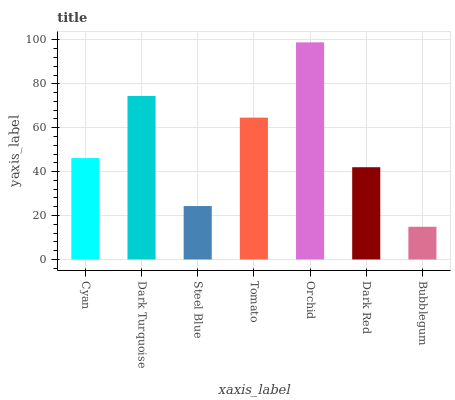Is Bubblegum the minimum?
Answer yes or no. Yes. Is Orchid the maximum?
Answer yes or no. Yes. Is Dark Turquoise the minimum?
Answer yes or no. No. Is Dark Turquoise the maximum?
Answer yes or no. No. Is Dark Turquoise greater than Cyan?
Answer yes or no. Yes. Is Cyan less than Dark Turquoise?
Answer yes or no. Yes. Is Cyan greater than Dark Turquoise?
Answer yes or no. No. Is Dark Turquoise less than Cyan?
Answer yes or no. No. Is Cyan the high median?
Answer yes or no. Yes. Is Cyan the low median?
Answer yes or no. Yes. Is Dark Red the high median?
Answer yes or no. No. Is Dark Red the low median?
Answer yes or no. No. 